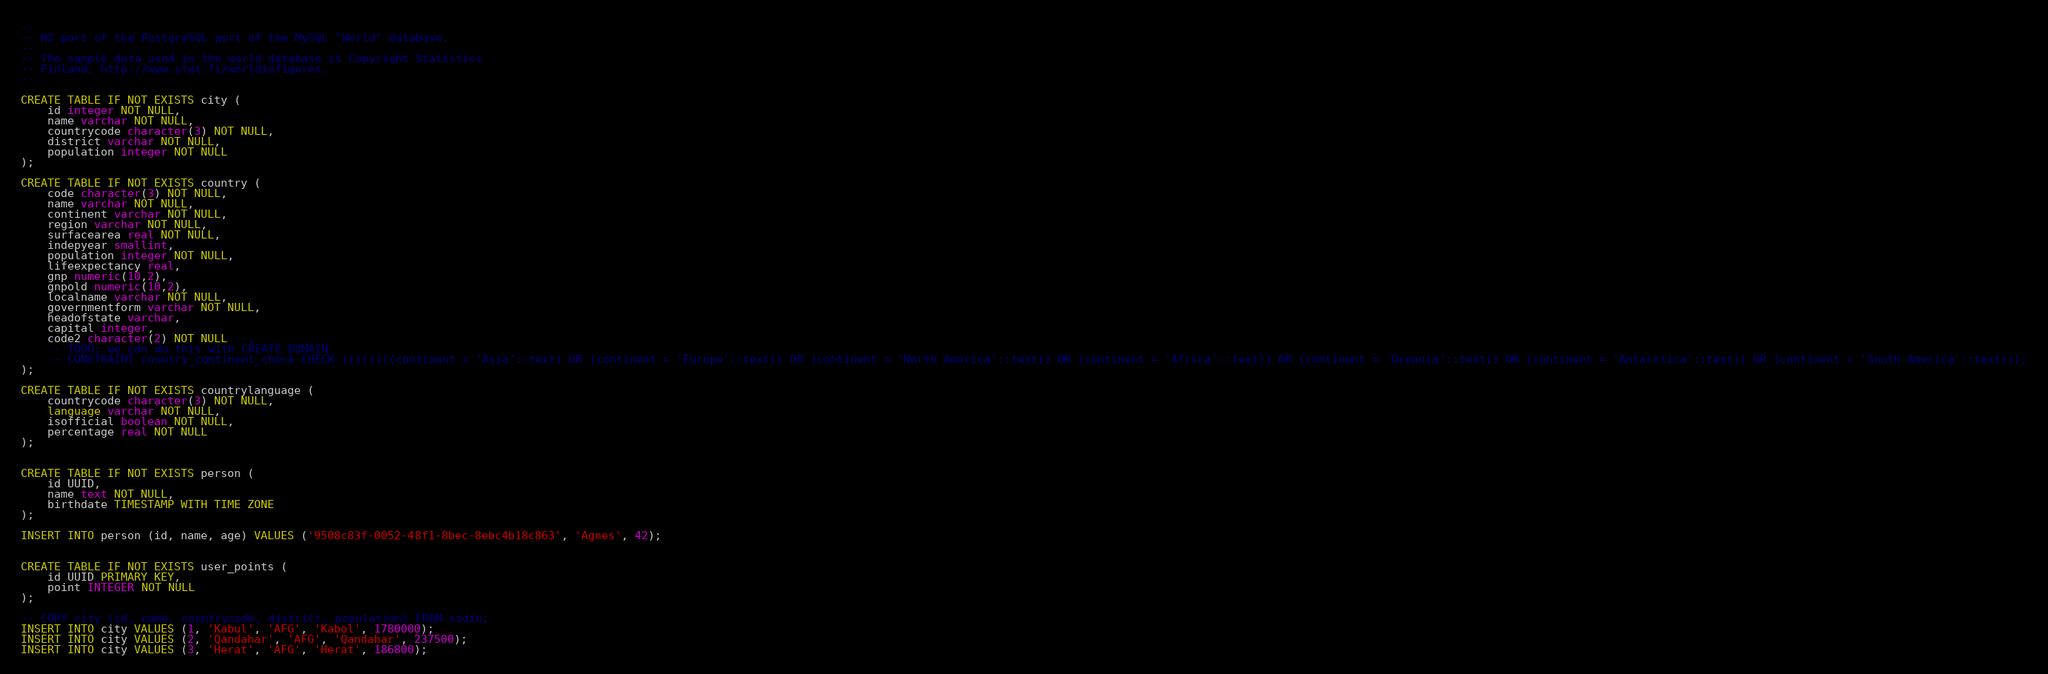<code> <loc_0><loc_0><loc_500><loc_500><_SQL_>--
-- H2 port of the PostgreSQL port of the MySQL "World" database.
--
-- The sample data used in the world database is Copyright Statistics 
-- Finland, http://www.stat.fi/worldinfigures.
--

CREATE TABLE IF NOT EXISTS city (
    id integer NOT NULL,
    name varchar NOT NULL,
    countrycode character(3) NOT NULL,
    district varchar NOT NULL,
    population integer NOT NULL
);

CREATE TABLE IF NOT EXISTS country (
    code character(3) NOT NULL,
    name varchar NOT NULL,
    continent varchar NOT NULL,
    region varchar NOT NULL,
    surfacearea real NOT NULL,
    indepyear smallint,
    population integer NOT NULL,
    lifeexpectancy real,
    gnp numeric(10,2),
    gnpold numeric(10,2),
    localname varchar NOT NULL,
    governmentform varchar NOT NULL,
    headofstate varchar,
    capital integer,
    code2 character(2) NOT NULL --,
    -- TODO: we can do this with CREATE DOMAIN
    -- CONSTRAINT country_continent_check CHECK ((((((((continent = 'Asia'::text) OR (continent = 'Europe'::text)) OR (continent = 'North America'::text)) OR (continent = 'Africa'::text)) OR (continent = 'Oceania'::text)) OR (continent = 'Antarctica'::text)) OR (continent = 'South America'::text)));
);

CREATE TABLE IF NOT EXISTS countrylanguage (
    countrycode character(3) NOT NULL,
    language varchar NOT NULL,
    isofficial boolean NOT NULL,
    percentage real NOT NULL
);


CREATE TABLE IF NOT EXISTS person (
    id UUID,
    name text NOT NULL,
    birthdate TIMESTAMP WITH TIME ZONE
);

INSERT INTO person (id, name, age) VALUES ('9508c83f-0052-48f1-8bec-8ebc4b18c863', 'Agnes', 42);


CREATE TABLE IF NOT EXISTS user_points (
    id UUID PRIMARY KEY,
    point INTEGER NOT NULL
);

-- COPY city (id, name, countrycode, district, population) FROM stdin;
INSERT INTO city VALUES (1, 'Kabul', 'AFG', 'Kabol', 1780000);
INSERT INTO city VALUES (2, 'Qandahar', 'AFG', 'Qandahar', 237500);
INSERT INTO city VALUES (3, 'Herat', 'AFG', 'Herat', 186800);</code> 